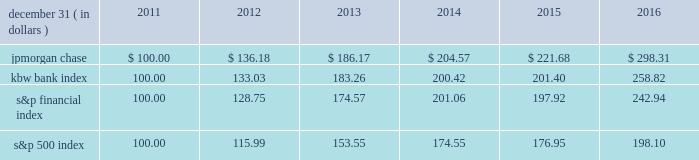Jpmorgan chase & co./2016 annual report 35 five-year stock performance the table and graph compare the five-year cumulative total return for jpmorgan chase & co .
( 201cjpmorgan chase 201d or the 201cfirm 201d ) common stock with the cumulative return of the s&p 500 index , the kbw bank index and the s&p financial index .
The s&p 500 index is a commonly referenced united states of america ( 201cu.s . 201d ) equity benchmark consisting of leading companies from different economic sectors .
The kbw bank index seeks to reflect the performance of banks and thrifts that are publicly traded in the u.s .
And is composed of leading national money center and regional banks and thrifts .
The s&p financial index is an index of financial companies , all of which are components of the s&p 500 .
The firm is a component of all three industry indices .
The table and graph assume simultaneous investments of $ 100 on december 31 , 2011 , in jpmorgan chase common stock and in each of the above indices .
The comparison assumes that all dividends are reinvested .
December 31 , ( in dollars ) 2011 2012 2013 2014 2015 2016 .
December 31 , ( in dollars ) .
Did jpmorgan chase outperform the kbw bank index 100.00?\\n? 
Computations: (298.31 > 258.82)
Answer: yes. 